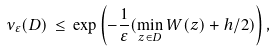Convert formula to latex. <formula><loc_0><loc_0><loc_500><loc_500>\nu _ { \varepsilon } ( D ) \, \leq \, \exp { \left ( - \frac { 1 } { \varepsilon } ( \min _ { z \in D } W ( z ) + h / 2 ) \right ) } \, ,</formula> 